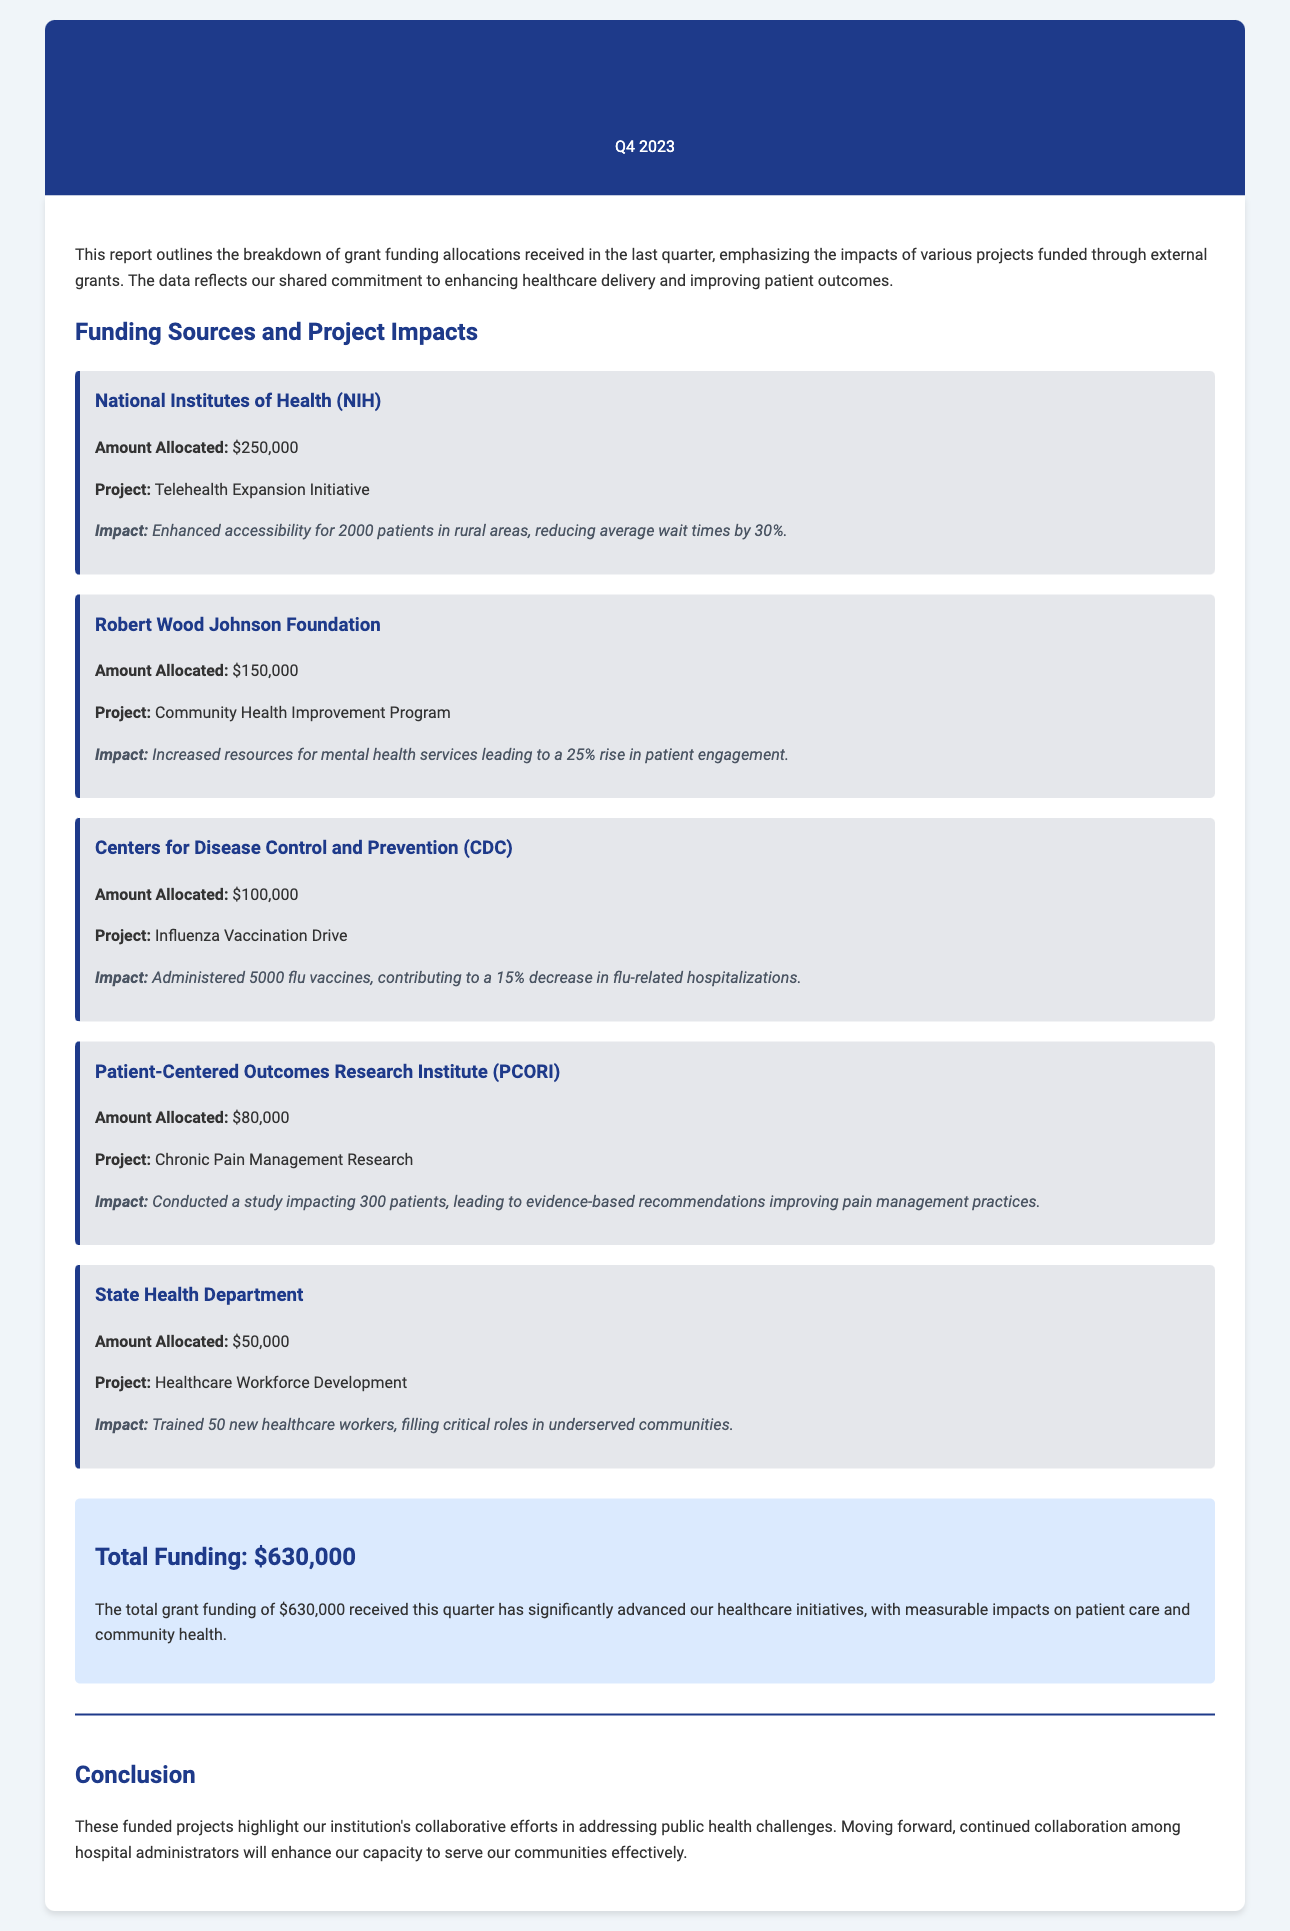What was the total amount allocated from the National Institutes of Health? The total amount allocated from the National Institutes of Health for the Telehealth Expansion Initiative is specified in the document as $250,000.
Answer: $250,000 How many patients did the Telehealth Expansion Initiative impact? The document states that the Telehealth Expansion Initiative enhanced accessibility for 2000 patients in rural areas.
Answer: 2000 patients What is the impact of the Community Health Improvement Program? The document highlights that the Community Health Improvement Program led to a 25% rise in patient engagement as a result of increased resources for mental health services.
Answer: 25% rise in patient engagement How many flu vaccines were administered during the Influenza Vaccination Drive? According to the document, 5000 flu vaccines were administered during the Influenza Vaccination Drive.
Answer: 5000 flu vaccines What was the total grant funding received in the last quarter? The total grant funding received in the last quarter is indicated in the document as $630,000, reflecting the sum of all allocations.
Answer: $630,000 What was the project focus of the funding from the Patient-Centered Outcomes Research Institute? The funding from PCORI focused on Chronic Pain Management Research.
Answer: Chronic Pain Management Research How many new healthcare workers were trained under the Healthcare Workforce Development project? The document states that 50 new healthcare workers were trained under the Healthcare Workforce Development project.
Answer: 50 new healthcare workers What was the funding amount allocated by the Centers for Disease Control and Prevention? The document specifies that the funding amount allocated by the CDC for the Influenza Vaccination Drive is $100,000.
Answer: $100,000 What does the conclusion of the report emphasize? The conclusion emphasizes the institution's collaborative efforts in addressing public health challenges and the importance of continued collaboration among hospital administrators.
Answer: Collaborative efforts in addressing public health challenges 